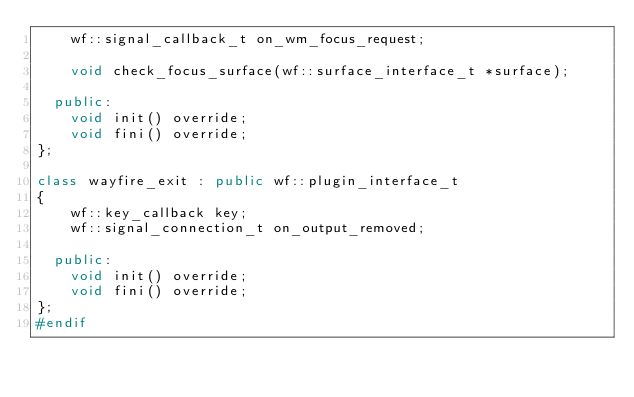Convert code to text. <code><loc_0><loc_0><loc_500><loc_500><_C++_>    wf::signal_callback_t on_wm_focus_request;

    void check_focus_surface(wf::surface_interface_t *surface);

  public:
    void init() override;
    void fini() override;
};

class wayfire_exit : public wf::plugin_interface_t
{
    wf::key_callback key;
    wf::signal_connection_t on_output_removed;

  public:
    void init() override;
    void fini() override;
};
#endif
</code> 